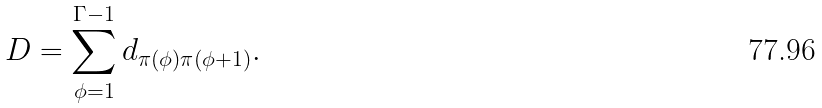Convert formula to latex. <formula><loc_0><loc_0><loc_500><loc_500>D = \sum _ { \phi = 1 } ^ { \Gamma - 1 } d _ { \pi ( \phi ) \pi ( \phi + 1 ) } .</formula> 